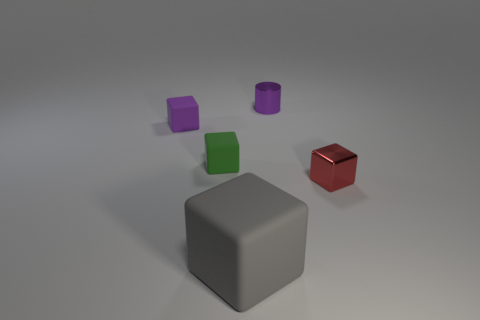Subtract 1 cubes. How many cubes are left? 3 Subtract all rubber blocks. How many blocks are left? 1 Subtract all green blocks. How many blocks are left? 3 Add 2 green rubber objects. How many objects exist? 7 Subtract all blue blocks. Subtract all purple balls. How many blocks are left? 4 Subtract all cubes. How many objects are left? 1 Add 5 big brown shiny balls. How many big brown shiny balls exist? 5 Subtract 1 purple blocks. How many objects are left? 4 Subtract all small purple metallic cylinders. Subtract all tiny things. How many objects are left? 0 Add 5 gray rubber objects. How many gray rubber objects are left? 6 